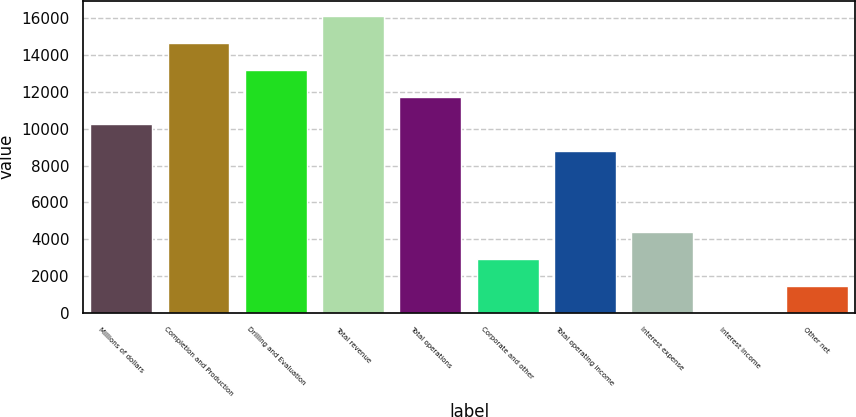<chart> <loc_0><loc_0><loc_500><loc_500><bar_chart><fcel>Millions of dollars<fcel>Completion and Production<fcel>Drilling and Evaluation<fcel>Total revenue<fcel>Total operations<fcel>Corporate and other<fcel>Total operating income<fcel>Interest expense<fcel>Interest income<fcel>Other net<nl><fcel>10276.1<fcel>14675<fcel>13208.7<fcel>16141.3<fcel>11742.4<fcel>2944.6<fcel>8809.8<fcel>4410.9<fcel>12<fcel>1478.3<nl></chart> 